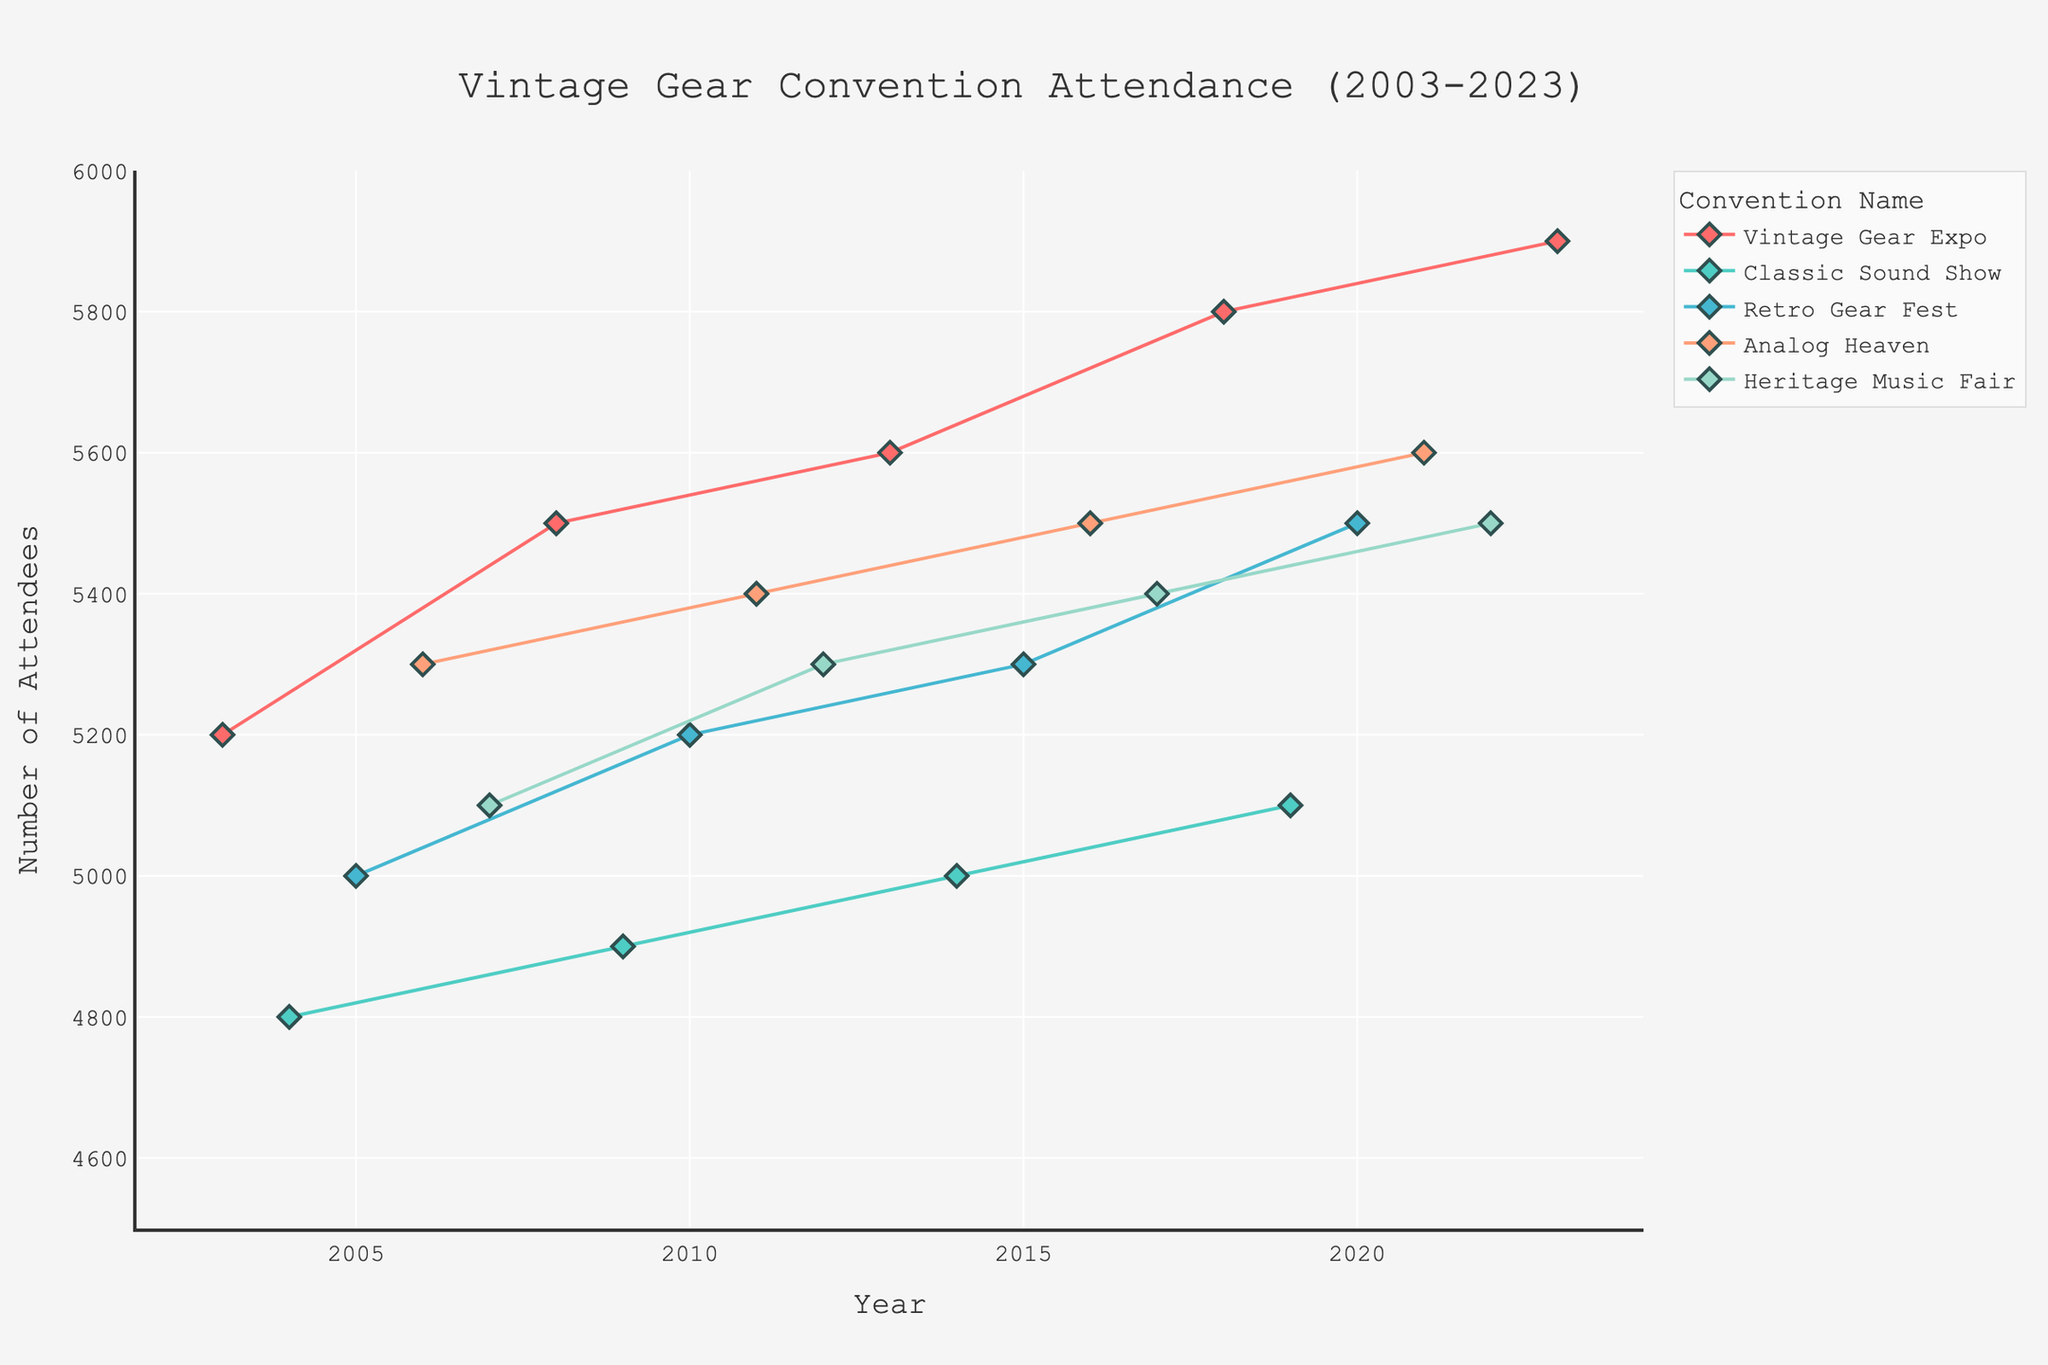What's the title of the figure? The title of the figure is prominently displayed at the top center of the plot.
Answer: Vintage Gear Convention Attendance (2003-2023) What are the x-axis and y-axis labels? The x-axis label is at the bottom center, and the y-axis label is at the left center of the plot.
Answer: Year; Number of Attendees Which convention had the highest attendance in 2023? Locate the data points for 2023 and compare the y-values. The highest y-value corresponds to the highest attendance.
Answer: Vintage Gear Expo How many conventions were tracked between 2003 and 2023? Count the number of unique lines or markers representing different conventions.
Answer: 5 Which year saw the lowest attendance overall? Find the data point with the lowest y-value across all years.
Answer: 2004 What's the average attendance for 'Analog Heaven' over the 20 years? Identify and sum all the "Analog Heaven" y-values, then divide by the number of data points (5).
Answer: (5300 + 5400 + 5500 + 5600) / 4 = 5450 What is the range in attendance numbers for the 'Classic Sound Show' convention? Identify the highest and lowest y-values for "Classic Sound Show" and calculate the difference.
Answer: 5100 - 4800 = 300 Which convention had the most consistent attendance over the years? Observe the variability in attendance numbers for each convention. The flattest line indicates the most consistency.
Answer: Heritage Music Fair Did any convention have a decreasing trend in attendance? Look for lines with a downward slope when moving from left to right.
Answer: No Which convention experienced the most significant increase in attendance from its first to its last occurrence? Compare the first and last y-values for each convention and identify the one with the largest difference.
Answer: Vintage Gear Expo 